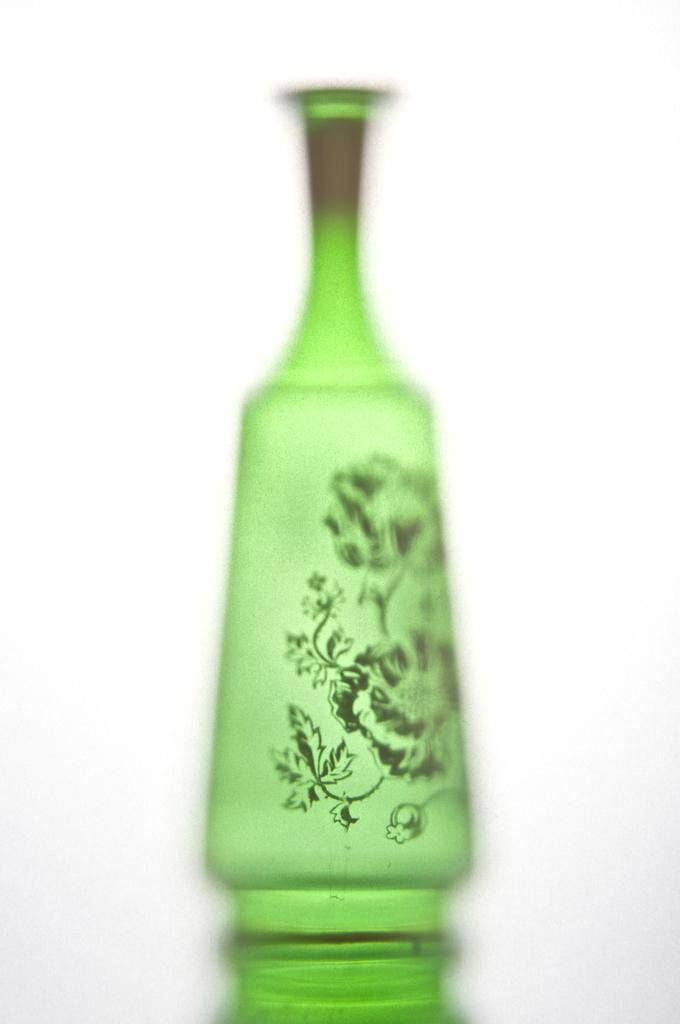What object is present in the image? There is a flower pot in the image. What is the color of the flower pot? The flower pot is green in color. What can be seen in the background of the image? The background of the image is white. How many fingers does the person in the image have? There is no person present in the image, only a flower pot. What is the relationship between the two brothers in the image? There are no brothers or any people present in the image, only a flower pot. 